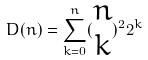Convert formula to latex. <formula><loc_0><loc_0><loc_500><loc_500>D ( n ) = \sum _ { k = 0 } ^ { n } ( \begin{matrix} n \\ k \end{matrix} ) ^ { 2 } 2 ^ { k }</formula> 